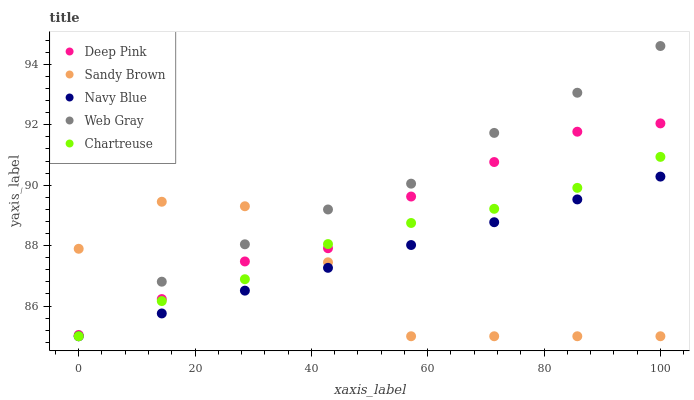Does Sandy Brown have the minimum area under the curve?
Answer yes or no. Yes. Does Web Gray have the maximum area under the curve?
Answer yes or no. Yes. Does Navy Blue have the minimum area under the curve?
Answer yes or no. No. Does Navy Blue have the maximum area under the curve?
Answer yes or no. No. Is Navy Blue the smoothest?
Answer yes or no. Yes. Is Sandy Brown the roughest?
Answer yes or no. Yes. Is Chartreuse the smoothest?
Answer yes or no. No. Is Chartreuse the roughest?
Answer yes or no. No. Does Web Gray have the lowest value?
Answer yes or no. Yes. Does Deep Pink have the lowest value?
Answer yes or no. No. Does Web Gray have the highest value?
Answer yes or no. Yes. Does Navy Blue have the highest value?
Answer yes or no. No. Is Navy Blue less than Deep Pink?
Answer yes or no. Yes. Is Deep Pink greater than Navy Blue?
Answer yes or no. Yes. Does Web Gray intersect Navy Blue?
Answer yes or no. Yes. Is Web Gray less than Navy Blue?
Answer yes or no. No. Is Web Gray greater than Navy Blue?
Answer yes or no. No. Does Navy Blue intersect Deep Pink?
Answer yes or no. No. 